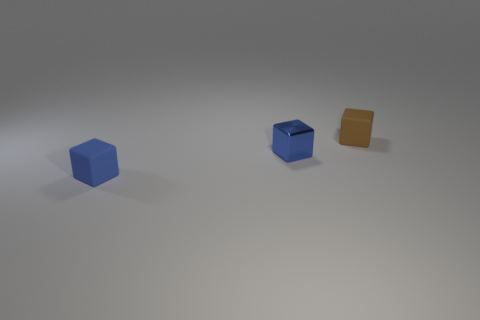Is the color of the small cube that is in front of the tiny metallic object the same as the metal block to the left of the brown object?
Your answer should be compact. Yes. Is the blue object behind the tiny blue matte object made of the same material as the small blue block that is in front of the metallic cube?
Offer a terse response. No. How many objects are either small matte things that are behind the tiny blue matte cube or small brown blocks?
Offer a very short reply. 1. How many objects are either brown things or blue shiny things behind the blue rubber cube?
Your answer should be compact. 2. How many other brown objects have the same size as the brown matte thing?
Keep it short and to the point. 0. Is the number of small brown things in front of the tiny brown cube less than the number of tiny blue matte blocks in front of the blue metallic object?
Ensure brevity in your answer.  Yes. What number of metal things are either tiny brown blocks or blue blocks?
Keep it short and to the point. 1. The small brown rubber thing is what shape?
Offer a terse response. Cube. What is the material of the blue cube that is the same size as the blue metal thing?
Your answer should be compact. Rubber. What number of big objects are either blue things or blue rubber cubes?
Offer a very short reply. 0. 